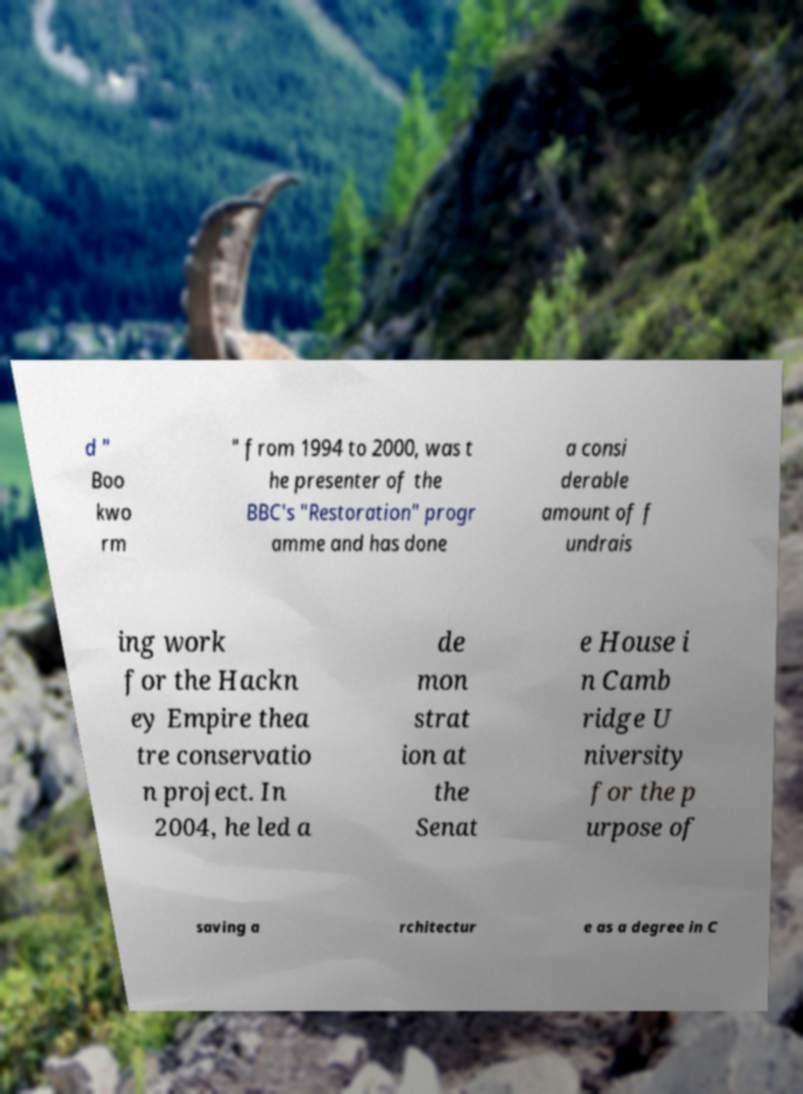Can you read and provide the text displayed in the image?This photo seems to have some interesting text. Can you extract and type it out for me? d " Boo kwo rm " from 1994 to 2000, was t he presenter of the BBC's "Restoration" progr amme and has done a consi derable amount of f undrais ing work for the Hackn ey Empire thea tre conservatio n project. In 2004, he led a de mon strat ion at the Senat e House i n Camb ridge U niversity for the p urpose of saving a rchitectur e as a degree in C 